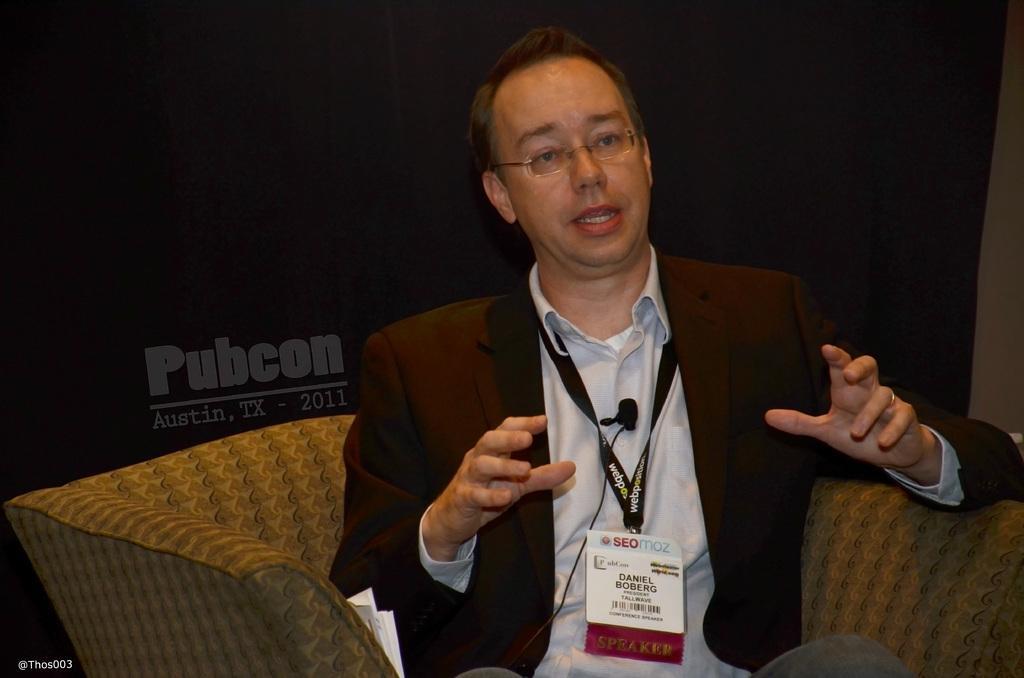Can you describe this image briefly? In this image, we can see a man sitting on the sofa, he is wearing a coat and I card. 